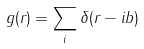<formula> <loc_0><loc_0><loc_500><loc_500>g ( r ) = \sum _ { i } \delta ( r - i b )</formula> 